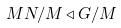<formula> <loc_0><loc_0><loc_500><loc_500>M N / M \triangleleft G / M</formula> 